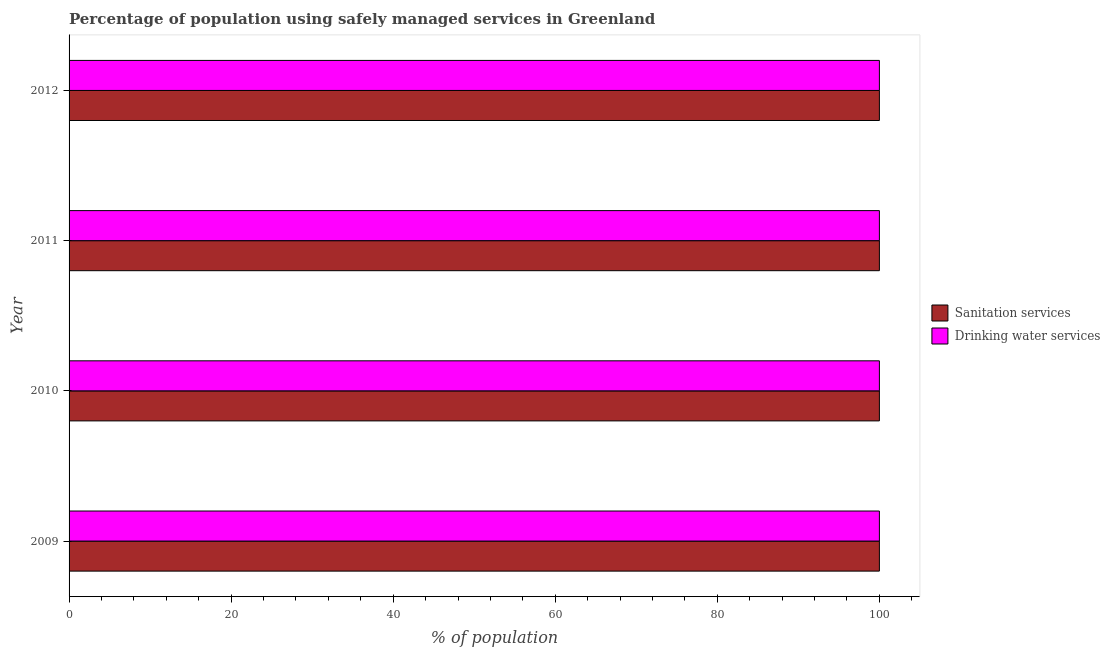How many different coloured bars are there?
Your answer should be compact. 2. Are the number of bars per tick equal to the number of legend labels?
Keep it short and to the point. Yes. How many bars are there on the 1st tick from the bottom?
Your answer should be compact. 2. What is the percentage of population who used sanitation services in 2012?
Make the answer very short. 100. Across all years, what is the maximum percentage of population who used sanitation services?
Offer a very short reply. 100. Across all years, what is the minimum percentage of population who used drinking water services?
Give a very brief answer. 100. In which year was the percentage of population who used sanitation services minimum?
Ensure brevity in your answer.  2009. What is the total percentage of population who used sanitation services in the graph?
Offer a terse response. 400. What is the average percentage of population who used drinking water services per year?
Keep it short and to the point. 100. What is the ratio of the percentage of population who used drinking water services in 2009 to that in 2010?
Keep it short and to the point. 1. Is the difference between the percentage of population who used sanitation services in 2011 and 2012 greater than the difference between the percentage of population who used drinking water services in 2011 and 2012?
Your response must be concise. No. What is the difference between the highest and the second highest percentage of population who used drinking water services?
Provide a short and direct response. 0. What is the difference between the highest and the lowest percentage of population who used drinking water services?
Ensure brevity in your answer.  0. Is the sum of the percentage of population who used sanitation services in 2009 and 2012 greater than the maximum percentage of population who used drinking water services across all years?
Give a very brief answer. Yes. What does the 2nd bar from the top in 2012 represents?
Your answer should be very brief. Sanitation services. What does the 1st bar from the bottom in 2009 represents?
Your answer should be very brief. Sanitation services. What is the difference between two consecutive major ticks on the X-axis?
Your answer should be compact. 20. Are the values on the major ticks of X-axis written in scientific E-notation?
Provide a succinct answer. No. Does the graph contain any zero values?
Offer a very short reply. No. Does the graph contain grids?
Your response must be concise. No. How many legend labels are there?
Provide a short and direct response. 2. What is the title of the graph?
Keep it short and to the point. Percentage of population using safely managed services in Greenland. What is the label or title of the X-axis?
Provide a succinct answer. % of population. What is the % of population of Sanitation services in 2009?
Provide a succinct answer. 100. What is the % of population of Drinking water services in 2009?
Keep it short and to the point. 100. What is the % of population in Drinking water services in 2011?
Make the answer very short. 100. What is the % of population of Sanitation services in 2012?
Ensure brevity in your answer.  100. Across all years, what is the maximum % of population in Sanitation services?
Your answer should be compact. 100. What is the difference between the % of population of Sanitation services in 2009 and that in 2010?
Provide a succinct answer. 0. What is the difference between the % of population of Sanitation services in 2009 and that in 2011?
Offer a terse response. 0. What is the difference between the % of population of Drinking water services in 2009 and that in 2011?
Your answer should be compact. 0. What is the difference between the % of population of Sanitation services in 2009 and that in 2012?
Provide a succinct answer. 0. What is the difference between the % of population in Drinking water services in 2009 and that in 2012?
Offer a very short reply. 0. What is the difference between the % of population in Sanitation services in 2010 and that in 2012?
Your answer should be compact. 0. What is the difference between the % of population of Sanitation services in 2009 and the % of population of Drinking water services in 2010?
Provide a succinct answer. 0. What is the difference between the % of population of Sanitation services in 2009 and the % of population of Drinking water services in 2011?
Provide a short and direct response. 0. What is the difference between the % of population in Sanitation services in 2010 and the % of population in Drinking water services in 2011?
Offer a very short reply. 0. What is the difference between the % of population of Sanitation services in 2010 and the % of population of Drinking water services in 2012?
Offer a very short reply. 0. In the year 2009, what is the difference between the % of population in Sanitation services and % of population in Drinking water services?
Your response must be concise. 0. In the year 2010, what is the difference between the % of population in Sanitation services and % of population in Drinking water services?
Your answer should be compact. 0. What is the ratio of the % of population of Sanitation services in 2009 to that in 2012?
Ensure brevity in your answer.  1. What is the ratio of the % of population in Drinking water services in 2009 to that in 2012?
Your answer should be very brief. 1. What is the ratio of the % of population in Sanitation services in 2010 to that in 2011?
Ensure brevity in your answer.  1. What is the ratio of the % of population of Sanitation services in 2010 to that in 2012?
Your answer should be compact. 1. What is the ratio of the % of population in Drinking water services in 2010 to that in 2012?
Your response must be concise. 1. What is the ratio of the % of population in Sanitation services in 2011 to that in 2012?
Make the answer very short. 1. What is the ratio of the % of population in Drinking water services in 2011 to that in 2012?
Keep it short and to the point. 1. What is the difference between the highest and the second highest % of population of Drinking water services?
Your answer should be compact. 0. What is the difference between the highest and the lowest % of population in Sanitation services?
Offer a terse response. 0. 